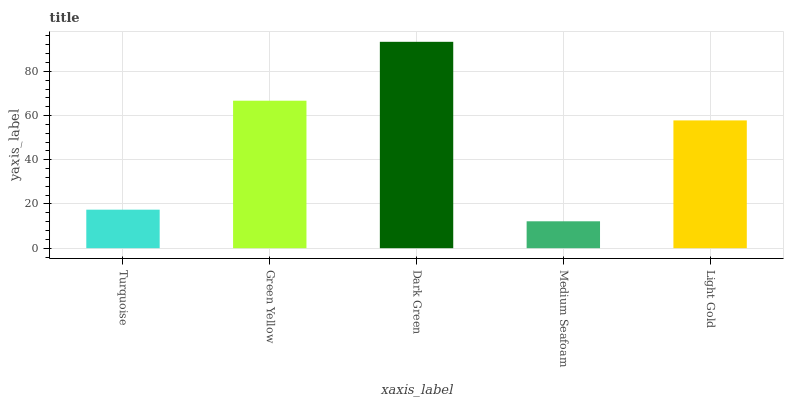Is Medium Seafoam the minimum?
Answer yes or no. Yes. Is Dark Green the maximum?
Answer yes or no. Yes. Is Green Yellow the minimum?
Answer yes or no. No. Is Green Yellow the maximum?
Answer yes or no. No. Is Green Yellow greater than Turquoise?
Answer yes or no. Yes. Is Turquoise less than Green Yellow?
Answer yes or no. Yes. Is Turquoise greater than Green Yellow?
Answer yes or no. No. Is Green Yellow less than Turquoise?
Answer yes or no. No. Is Light Gold the high median?
Answer yes or no. Yes. Is Light Gold the low median?
Answer yes or no. Yes. Is Green Yellow the high median?
Answer yes or no. No. Is Green Yellow the low median?
Answer yes or no. No. 